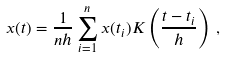<formula> <loc_0><loc_0><loc_500><loc_500>x ( t ) = \frac { 1 } { n h } \sum _ { i = 1 } ^ { n } x ( t _ { i } ) K \left ( \frac { t - t _ { i } } { h } \right ) \, ,</formula> 